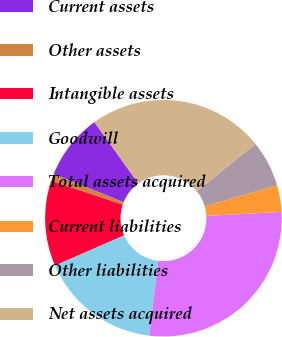Convert chart to OTSL. <chart><loc_0><loc_0><loc_500><loc_500><pie_chart><fcel>Current assets<fcel>Other assets<fcel>Intangible assets<fcel>Goodwill<fcel>Total assets acquired<fcel>Current liabilities<fcel>Other liabilities<fcel>Net assets acquired<nl><fcel>9.0%<fcel>0.96%<fcel>11.68%<fcel>16.52%<fcel>27.76%<fcel>3.64%<fcel>6.32%<fcel>24.11%<nl></chart> 